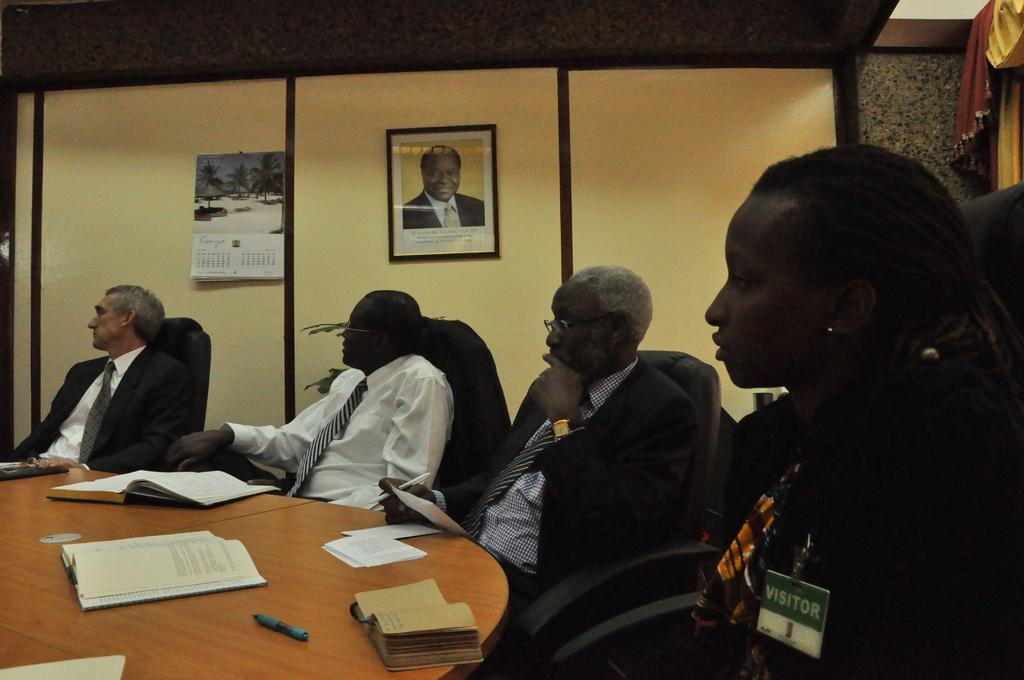What can be seen in the foreground of the picture? In the foreground of the picture, there are people, chairs, books, a table, and a pen. What is the people's position in relation to the other objects? The people are in the foreground of the picture, along with the chairs, books, table, and pen. What is present in the background of the picture? In the background of the picture, there is a frame, a calendar, and a curtain on the right side. Can you describe the curtain in the picture? The curtain is on the right side of the picture. What level of fear can be observed in the dog in the picture? There is no dog present in the picture, so it is not possible to determine the level of fear. What type of level is the picture taken from? The facts provided do not mention the level or perspective from which the picture was taken. 